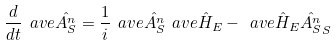<formula> <loc_0><loc_0><loc_500><loc_500>\frac { d } { d t } \ a v e { \hat { A ^ { n } _ { S } } } = \frac { 1 } { i } \ a v e { \hat { A ^ { n } _ { S } } \ a v e { \hat { H } } _ { E } - \ a v e { \hat { H } } _ { E } \hat { A ^ { n } _ { S } } } _ { S }</formula> 